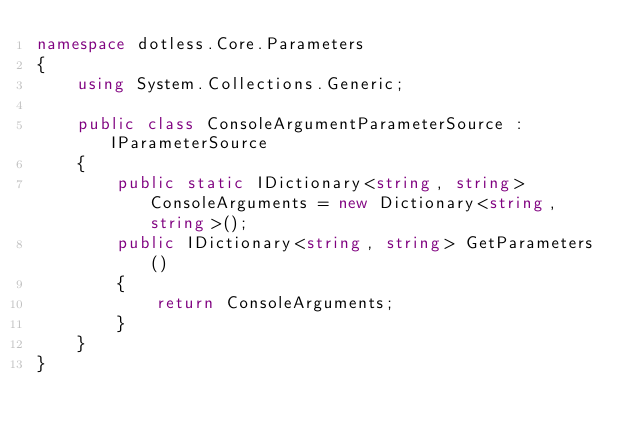Convert code to text. <code><loc_0><loc_0><loc_500><loc_500><_C#_>namespace dotless.Core.Parameters
{
    using System.Collections.Generic;

    public class ConsoleArgumentParameterSource : IParameterSource
    {
        public static IDictionary<string, string> ConsoleArguments = new Dictionary<string, string>();
        public IDictionary<string, string> GetParameters()
        {
            return ConsoleArguments;
        }
    }
}</code> 